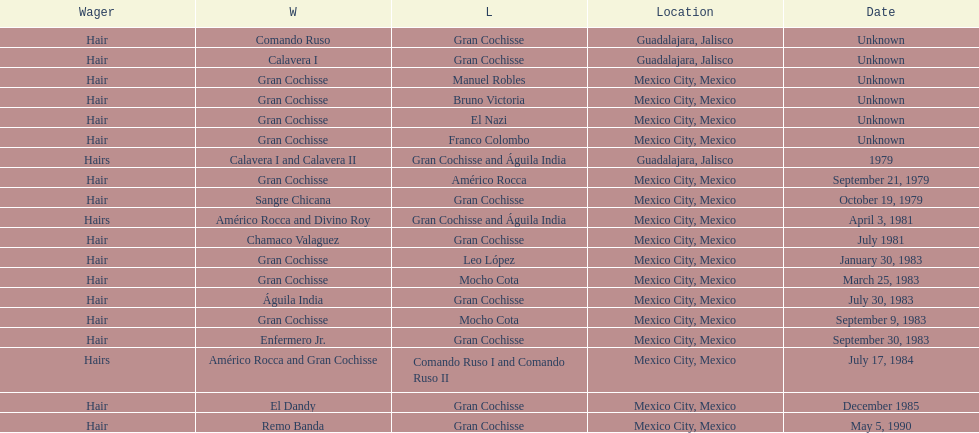How many times has gran cochisse been a winner? 9. 